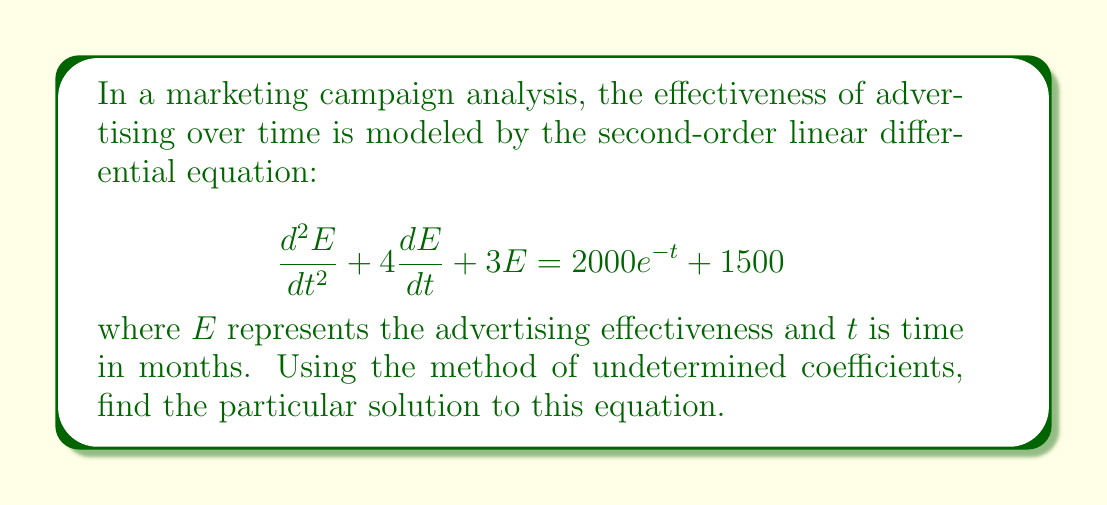Provide a solution to this math problem. To solve this second-order linear equation using the method of undetermined coefficients, we follow these steps:

1) First, identify the form of the particular solution based on the right-hand side of the equation. We have two terms:
   - $2000e^{-t}$: This suggests a term of the form $Ae^{-t}$
   - $1500$: This suggests a constant term $B$

   So, our particular solution will have the form:
   $$E_p = Ae^{-t} + B$$

2) Calculate the first and second derivatives of $E_p$:
   $$\frac{dE_p}{dt} = -Ae^{-t}$$
   $$\frac{d^2E_p}{dt^2} = Ae^{-t}$$

3) Substitute these into the original equation:
   $$(Ae^{-t}) + 4(-Ae^{-t}) + 3(Ae^{-t} + B) = 2000e^{-t} + 1500$$

4) Collect like terms:
   $$(A - 4A + 3A)e^{-t} + 3B = 2000e^{-t} + 1500$$

5) Equate coefficients:
   For $e^{-t}$ terms: $0A = 2000$, so $A = 2000$
   For constant terms: $3B = 1500$, so $B = 500$

6) Therefore, the particular solution is:
   $$E_p = 2000e^{-t} + 500$$

This solution represents the steady-state response of the advertising effectiveness to the given input. The term $2000e^{-t}$ shows an initial boost that decays over time, while the constant 500 represents a sustained baseline effect.
Answer: $$E_p = 2000e^{-t} + 500$$ 